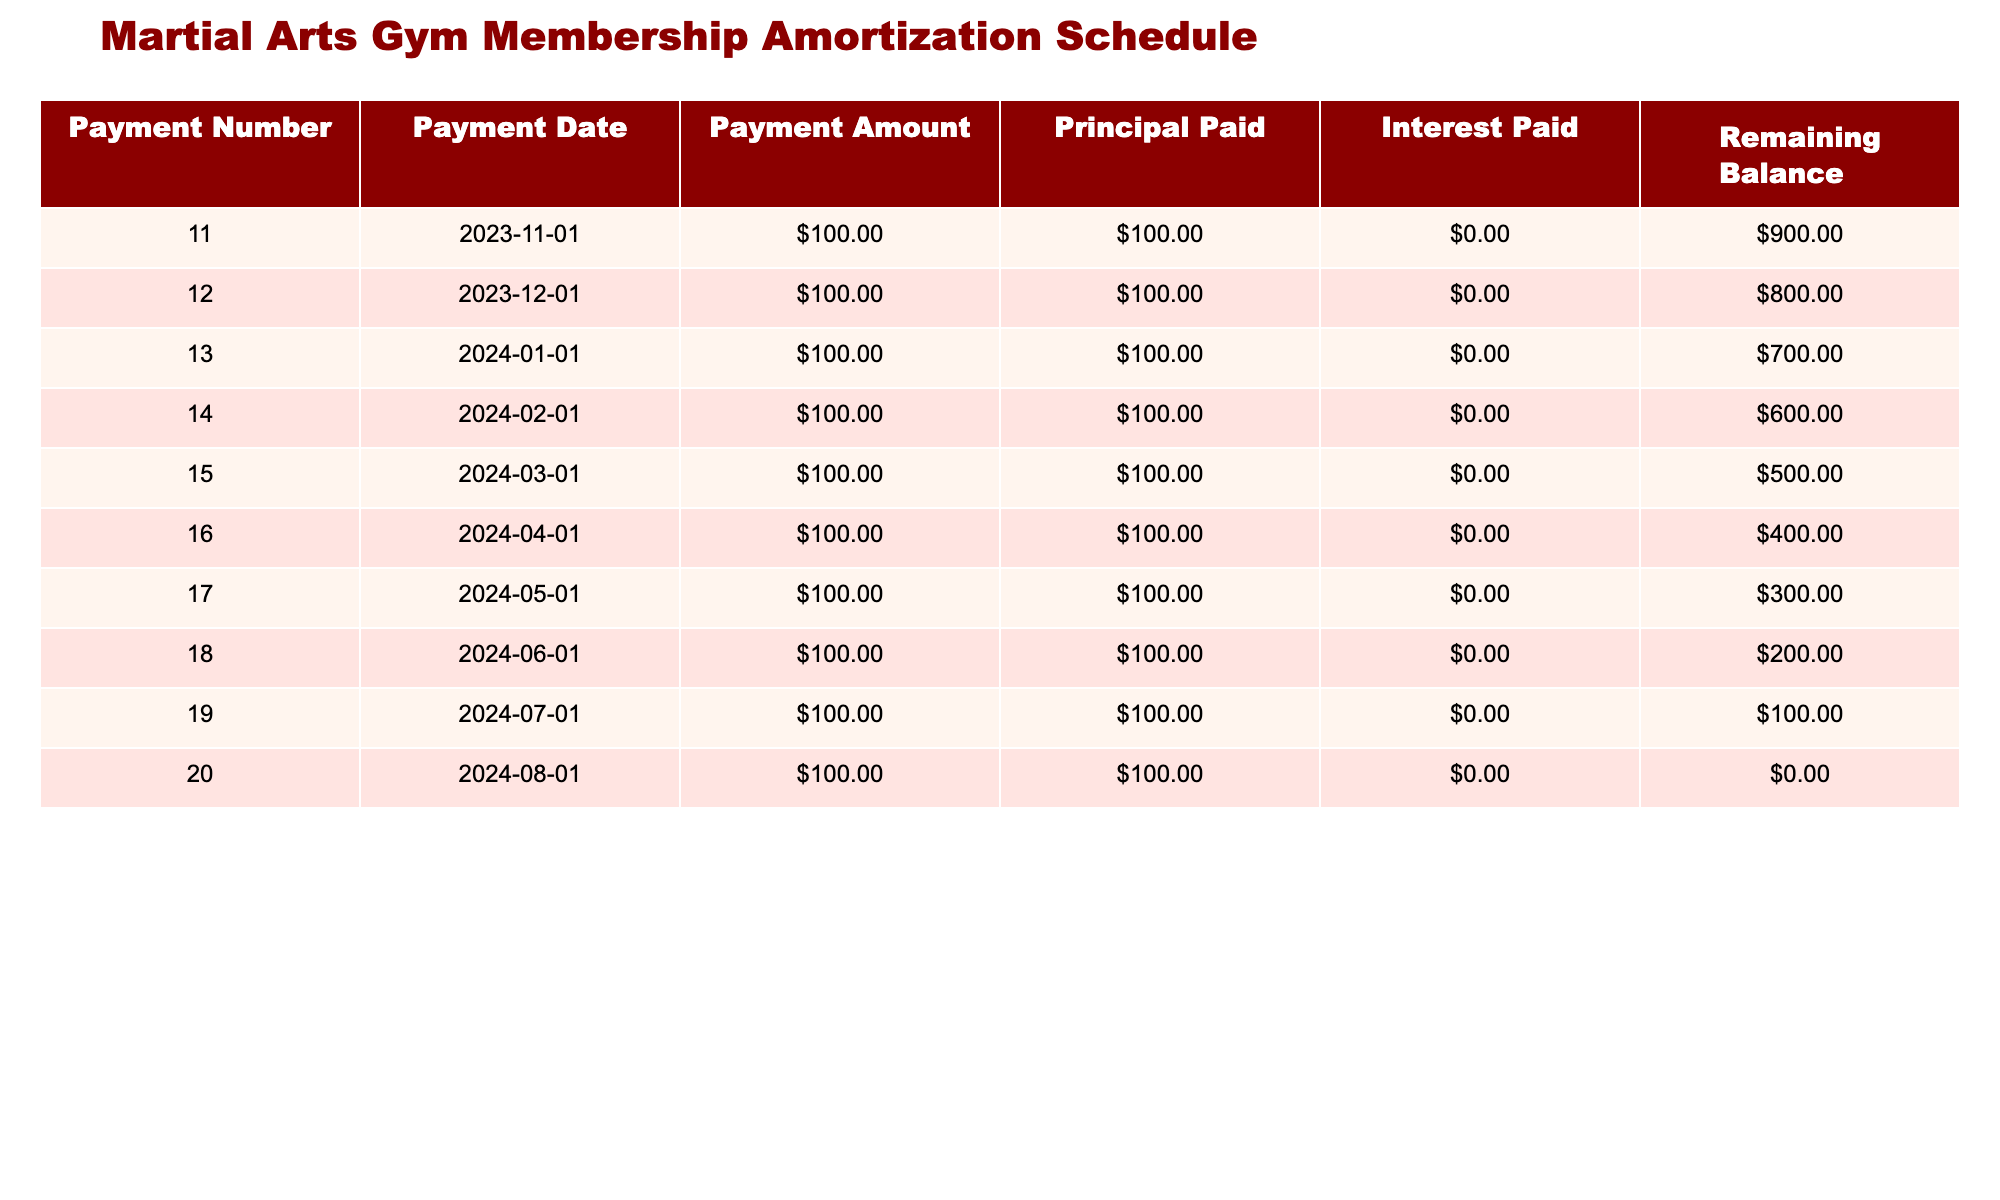What is the payment amount for payment number 15? The payment amount for payment number 15 is listed directly in the "Payment Amount" column for that row as $100.00.
Answer: $100.00 How much principal has been paid by the last payment? The last payment is payment number 20, and from the "Principal Paid" column for that row, it shows that $100.00 has been paid.
Answer: $100.00 Is it true that the remaining balance after payment number 18 is less than $300? The remaining balance after payment number 18 is $200.00, which is indeed less than $300. Thus, the statement is true.
Answer: Yes What is the total amount paid by payment number 12? To find the total amount paid by payment number 12, we add the payment amounts from payment numbers 11 and 12: $100.00 (11) + $100.00 (12) = $200.00.
Answer: $200.00 How many payments have been made by the date of the last entry in the table? The last entry in the table is payment number 20, indicating that a total of 20 payments have been made up to that point.
Answer: 20 What is the remaining balance after payment number 14? The remaining balance after payment number 14 is $600.00, which is specified in the "Remaining Balance" column for that row.
Answer: $600.00 What is the average principal paid per payment for the first ten payments? Since all payments show a principal payment of $100.00, the average is calculated as (100.00 * 10) / 10 = $100.00.
Answer: $100.00 If payments continued beyond payment number 20 with the same amount, how many payments would be required to completely pay off the remaining balance of $0.00? Since the remaining balance after payment number 20 is $0.00, no additional payments would be needed. Thus, it would take zero more payments.
Answer: 0 What is the interest paid for the first five payments? The interest paid for each of the first five payments is $0.00, and since there are five payments, the total is 0.00 * 5 = $0.00.
Answer: $0.00 